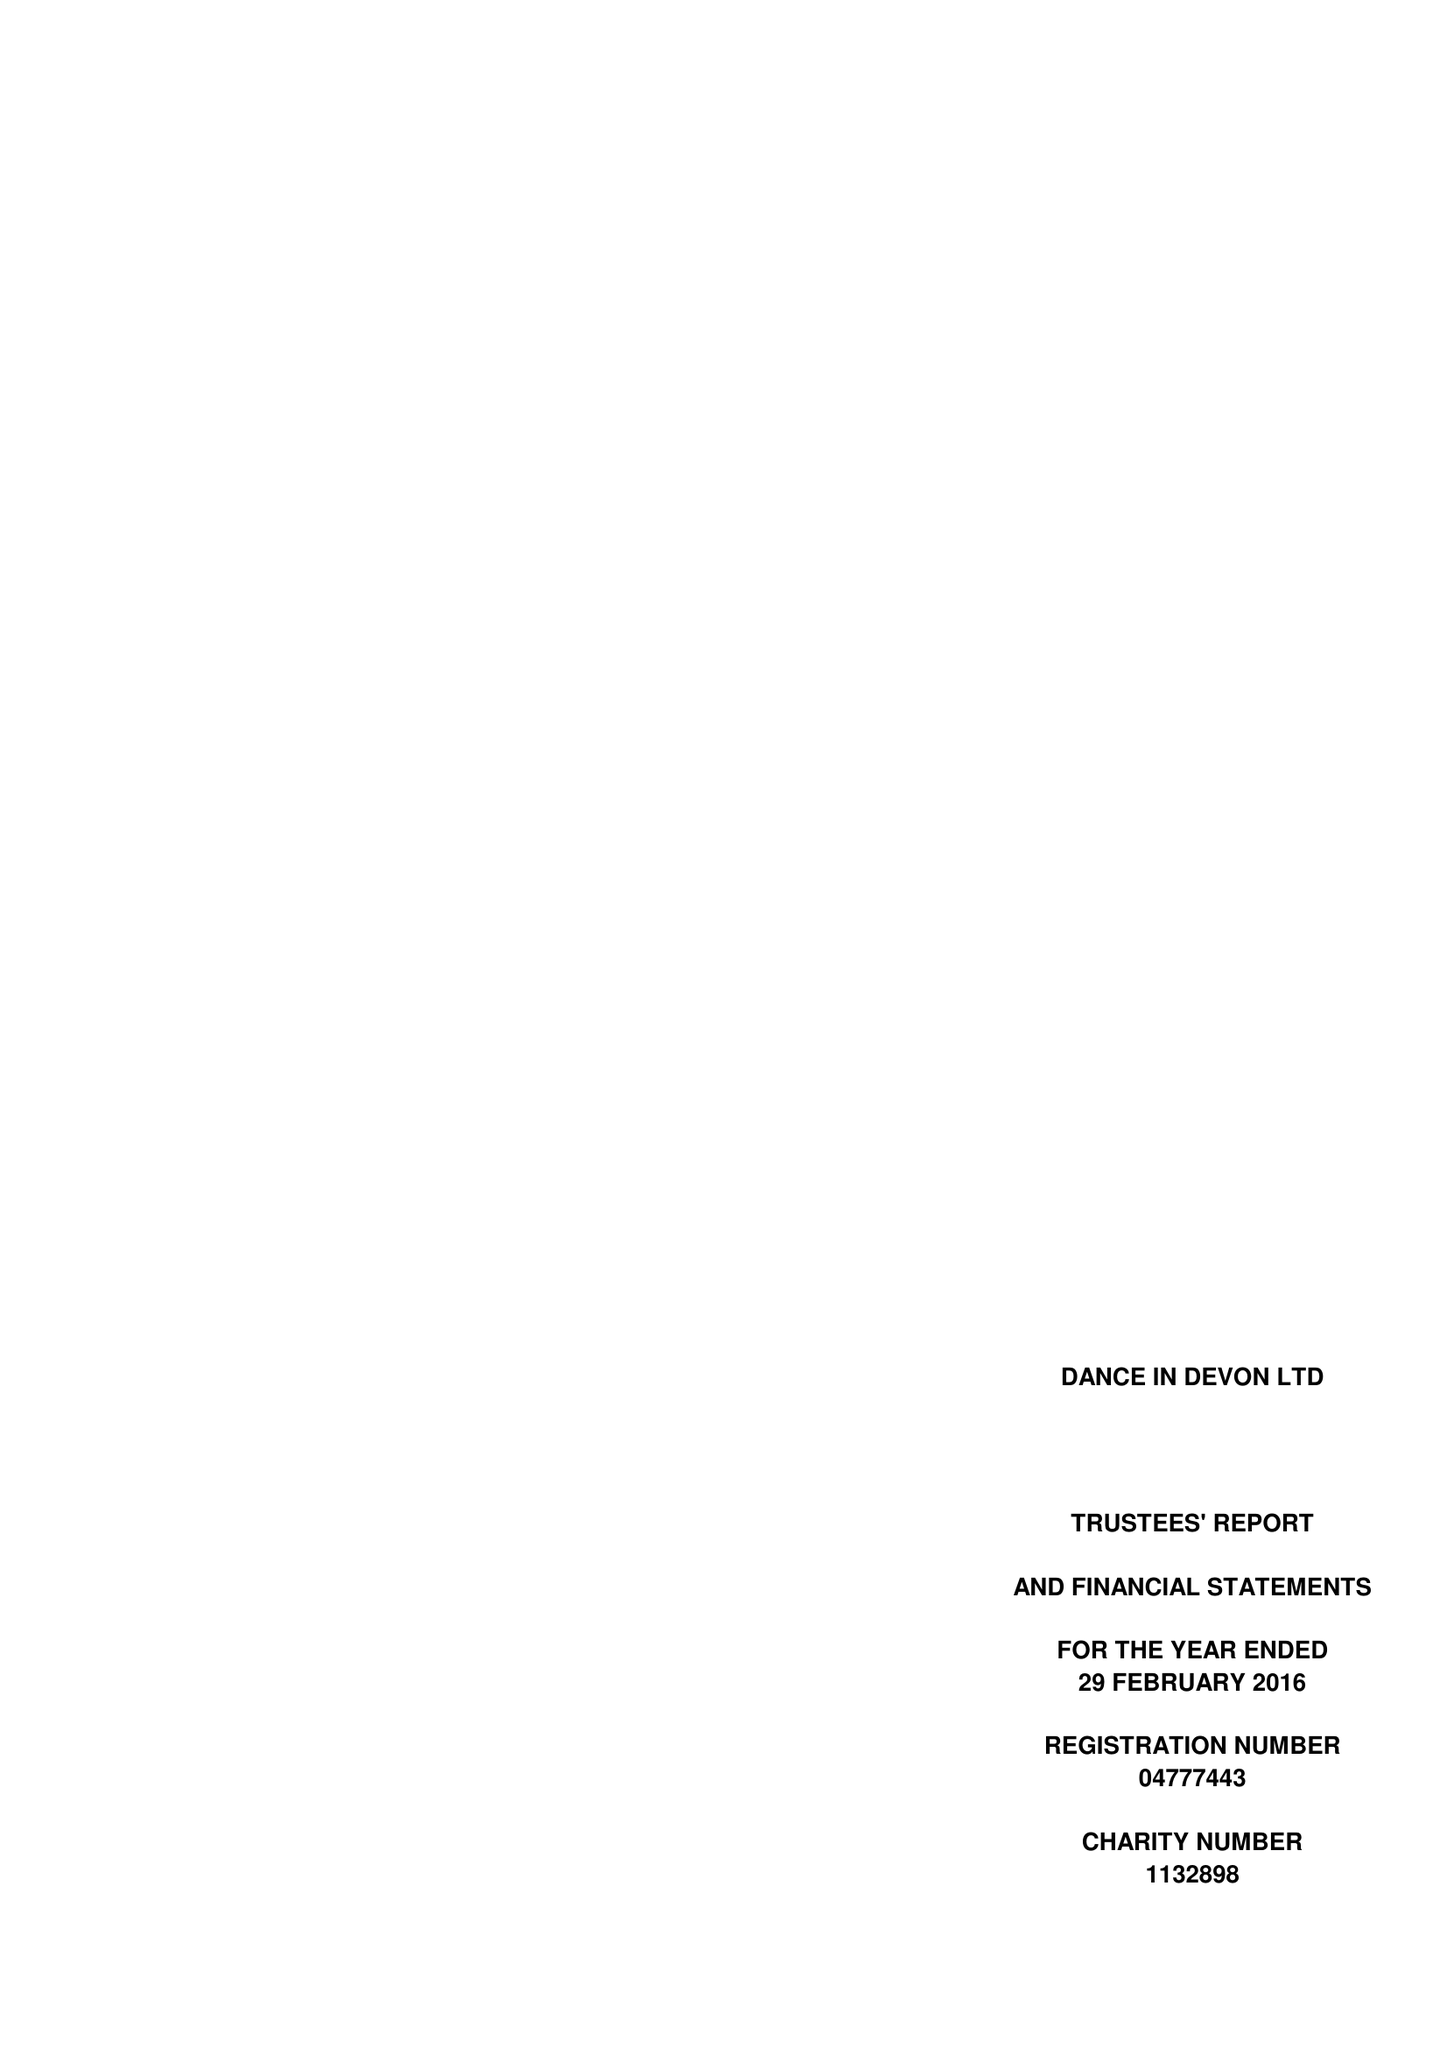What is the value for the spending_annually_in_british_pounds?
Answer the question using a single word or phrase. 98263.00 